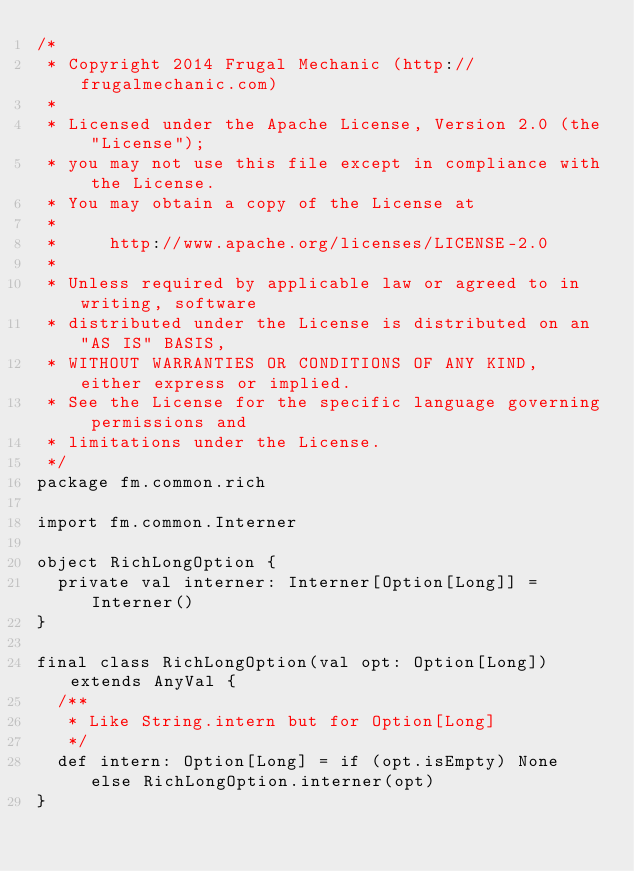<code> <loc_0><loc_0><loc_500><loc_500><_Scala_>/*
 * Copyright 2014 Frugal Mechanic (http://frugalmechanic.com)
 *
 * Licensed under the Apache License, Version 2.0 (the "License");
 * you may not use this file except in compliance with the License.
 * You may obtain a copy of the License at
 *
 *     http://www.apache.org/licenses/LICENSE-2.0
 *
 * Unless required by applicable law or agreed to in writing, software
 * distributed under the License is distributed on an "AS IS" BASIS,
 * WITHOUT WARRANTIES OR CONDITIONS OF ANY KIND, either express or implied.
 * See the License for the specific language governing permissions and
 * limitations under the License.
 */
package fm.common.rich

import fm.common.Interner

object RichLongOption {
  private val interner: Interner[Option[Long]] = Interner()
}

final class RichLongOption(val opt: Option[Long]) extends AnyVal {
  /**
   * Like String.intern but for Option[Long]
   */
  def intern: Option[Long] = if (opt.isEmpty) None else RichLongOption.interner(opt)
}</code> 